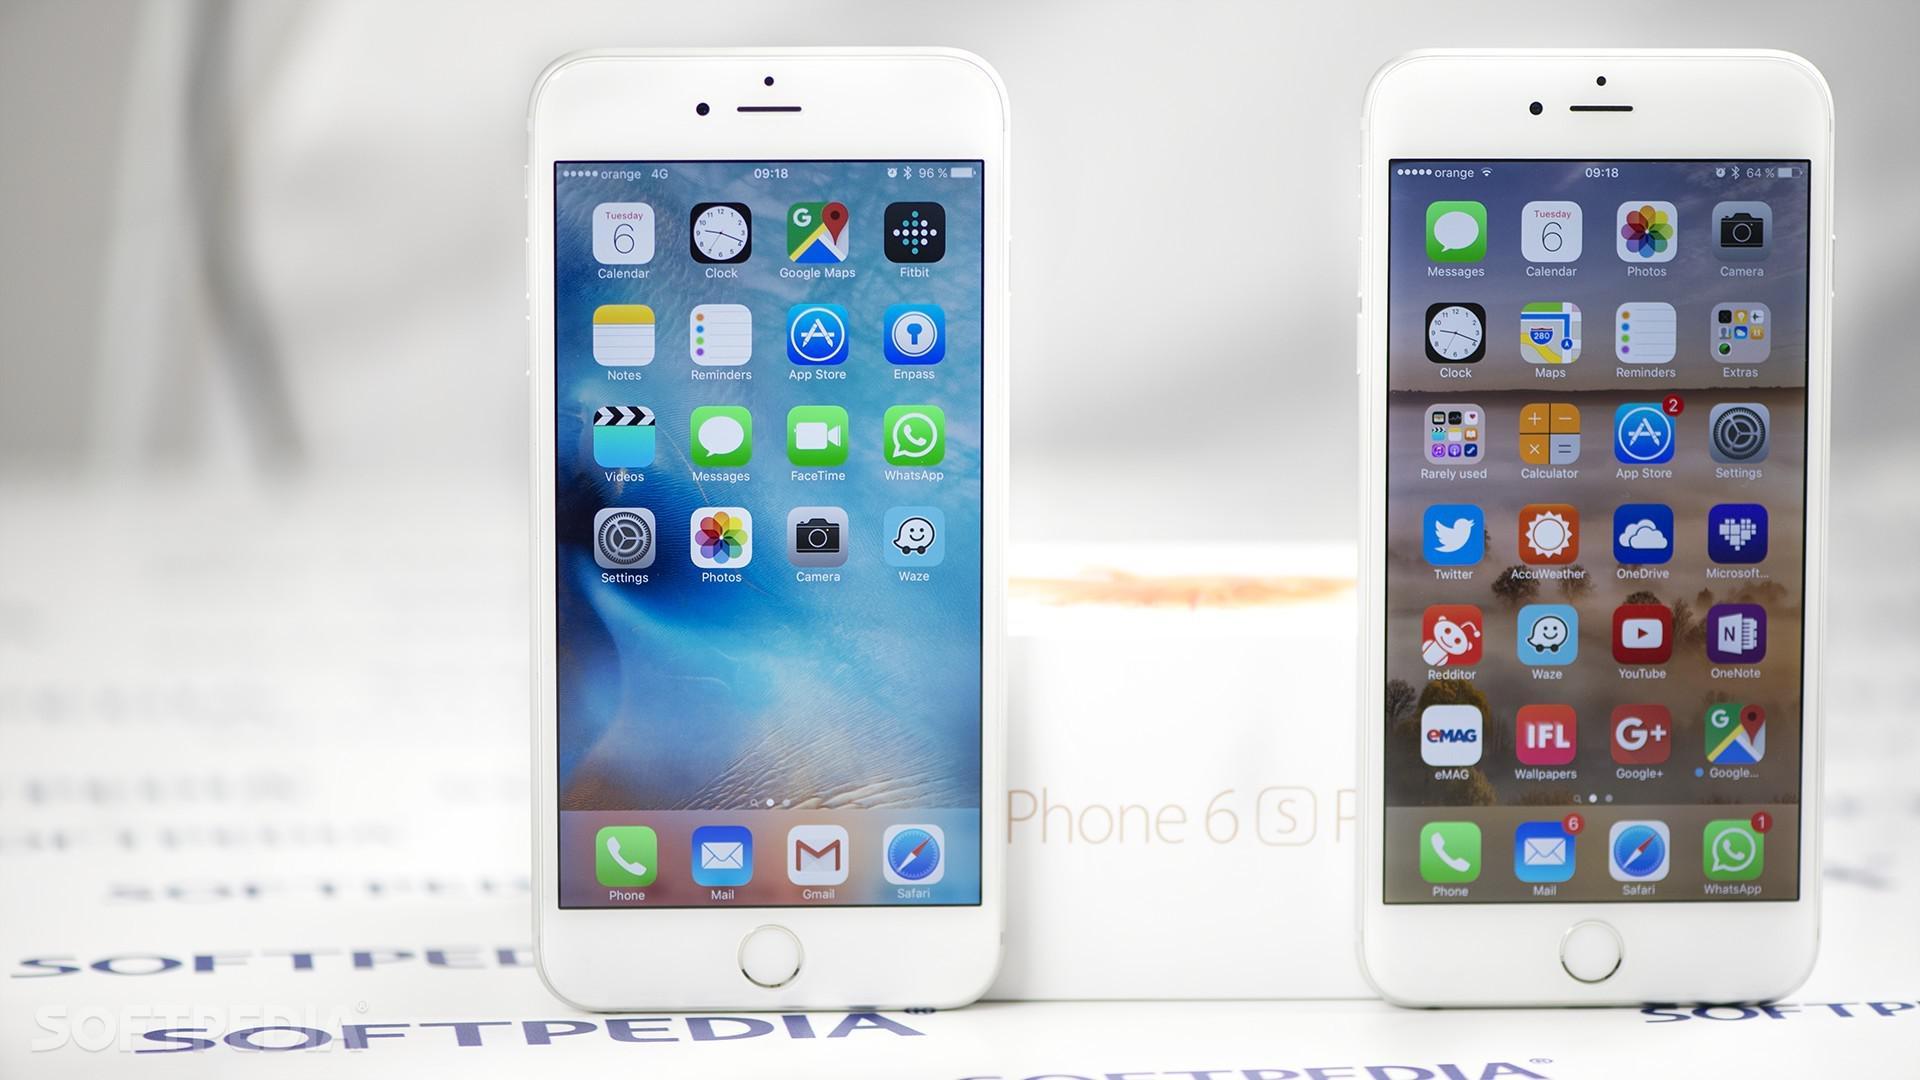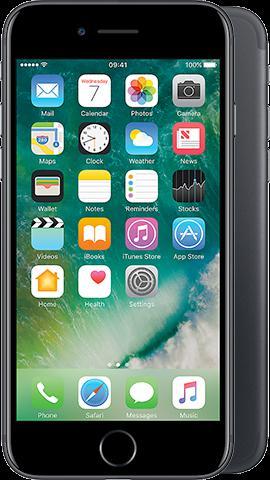The first image is the image on the left, the second image is the image on the right. For the images shown, is this caption "There are more phones in the image on the left." true? Answer yes or no. Yes. 